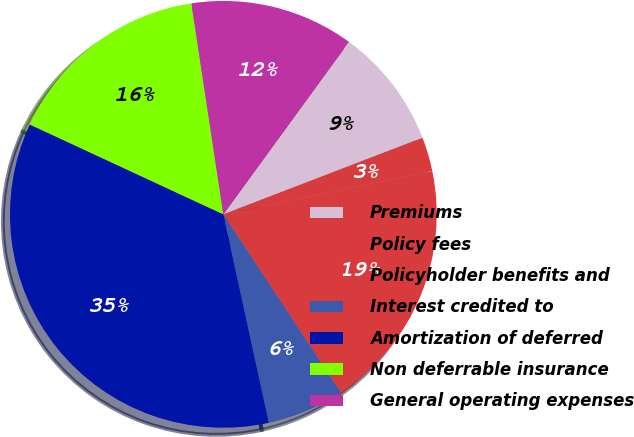Convert chart. <chart><loc_0><loc_0><loc_500><loc_500><pie_chart><fcel>Premiums<fcel>Policy fees<fcel>Policyholder benefits and<fcel>Interest credited to<fcel>Amortization of deferred<fcel>Non deferrable insurance<fcel>General operating expenses<nl><fcel>9.14%<fcel>2.59%<fcel>18.97%<fcel>5.86%<fcel>35.34%<fcel>15.69%<fcel>12.41%<nl></chart> 